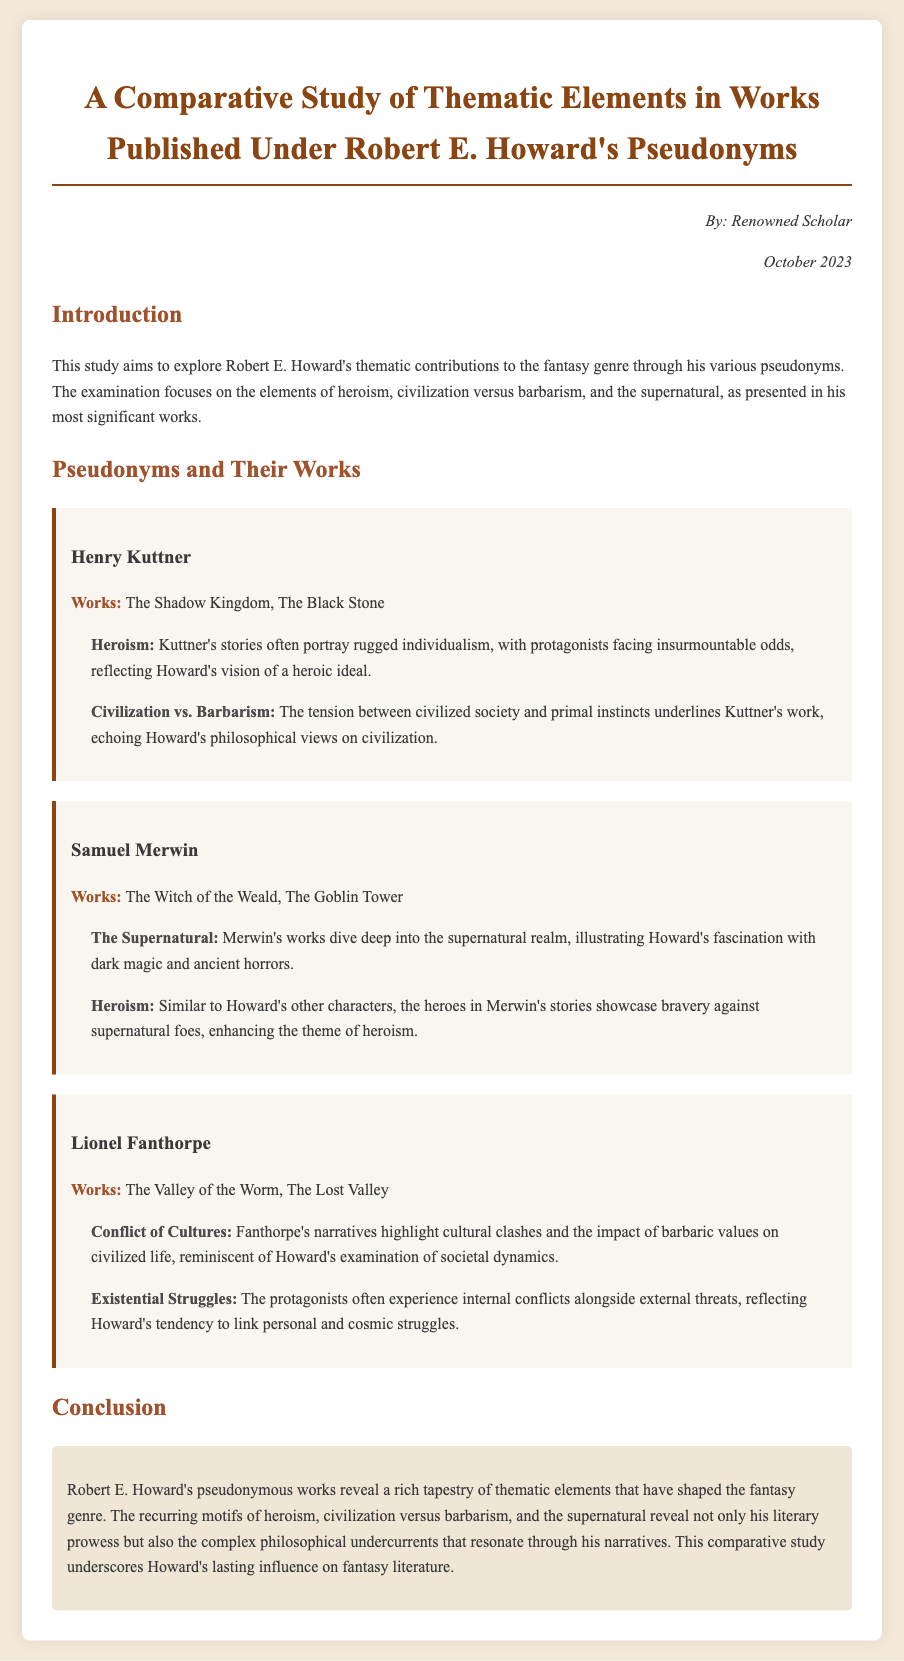What is the title of the study? The title of the study is explicitly mentioned in the heading of the document, describing its comparative nature concerning Robert E. Howard's pseudonyms.
Answer: A Comparative Study of Thematic Elements in Works Published Under Robert E. Howard's Pseudonyms Who authored the study? The author of the study is identified in the author-date section, reflecting the academic nature of the document.
Answer: Renowned Scholar In which month and year was the study published? The publication date is provided in the author-date section, indicating when the study was completed.
Answer: October 2023 What pseudonym is associated with "The Shadow Kingdom"? The work is linked to a specific pseudonym in the Pseudonyms and Their Works section, showcasing Howard's variation in authorship.
Answer: Henry Kuttner What theme is prominently explored in Samuel Merwin's works? The theme associated with Merwin's works is explicitly mentioned under the respective pseudonym, indicating its relevance to Howard's broader themes.
Answer: The Supernatural Which thematic element is associated with Lionel Fanthorpe's narratives? The thematic element is directly mentioned in relation to Fanthorpe's stories, highlighting conflicts in societal dynamics relevant to Howard's philosophy.
Answer: Conflict of Cultures What central conflict is highlighted in the works of Henry Kuttner? The central conflict discussed in Kuttner's works is clearly identified in the theme section, providing insight into Howard's overarching themes.
Answer: Civilization vs. Barbarism What recurring motifs shaped the fantasy genre according to the study? The study summarizes significant thematic elements in the conclusion, reflecting on their impact on the literary genre.
Answer: Heroism, civilization versus barbarism, and the supernatural 